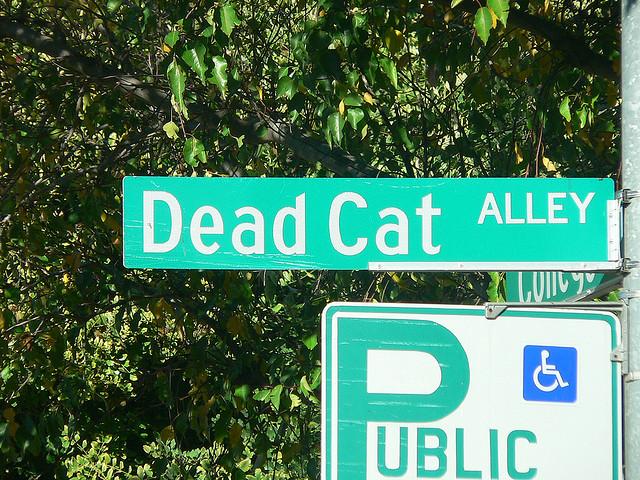What city are these streets in?
Be succinct. Not possible. What is the name of the street?
Answer briefly. Dead cat alley. Is someone walking in the picture?
Quick response, please. No. Is this a street or an alley?
Quick response, please. Alley. 